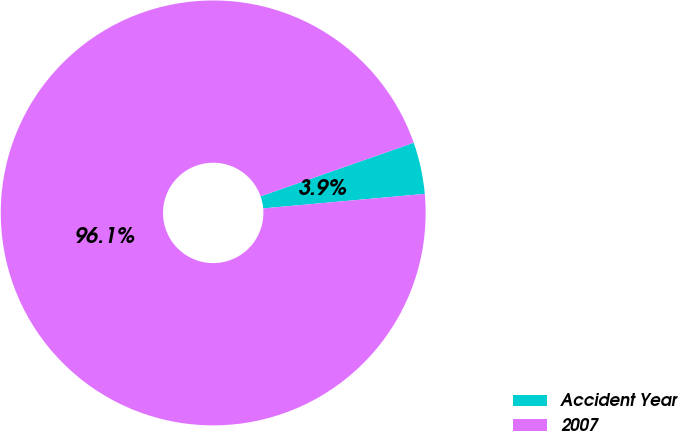Convert chart to OTSL. <chart><loc_0><loc_0><loc_500><loc_500><pie_chart><fcel>Accident Year<fcel>2007<nl><fcel>3.93%<fcel>96.07%<nl></chart> 